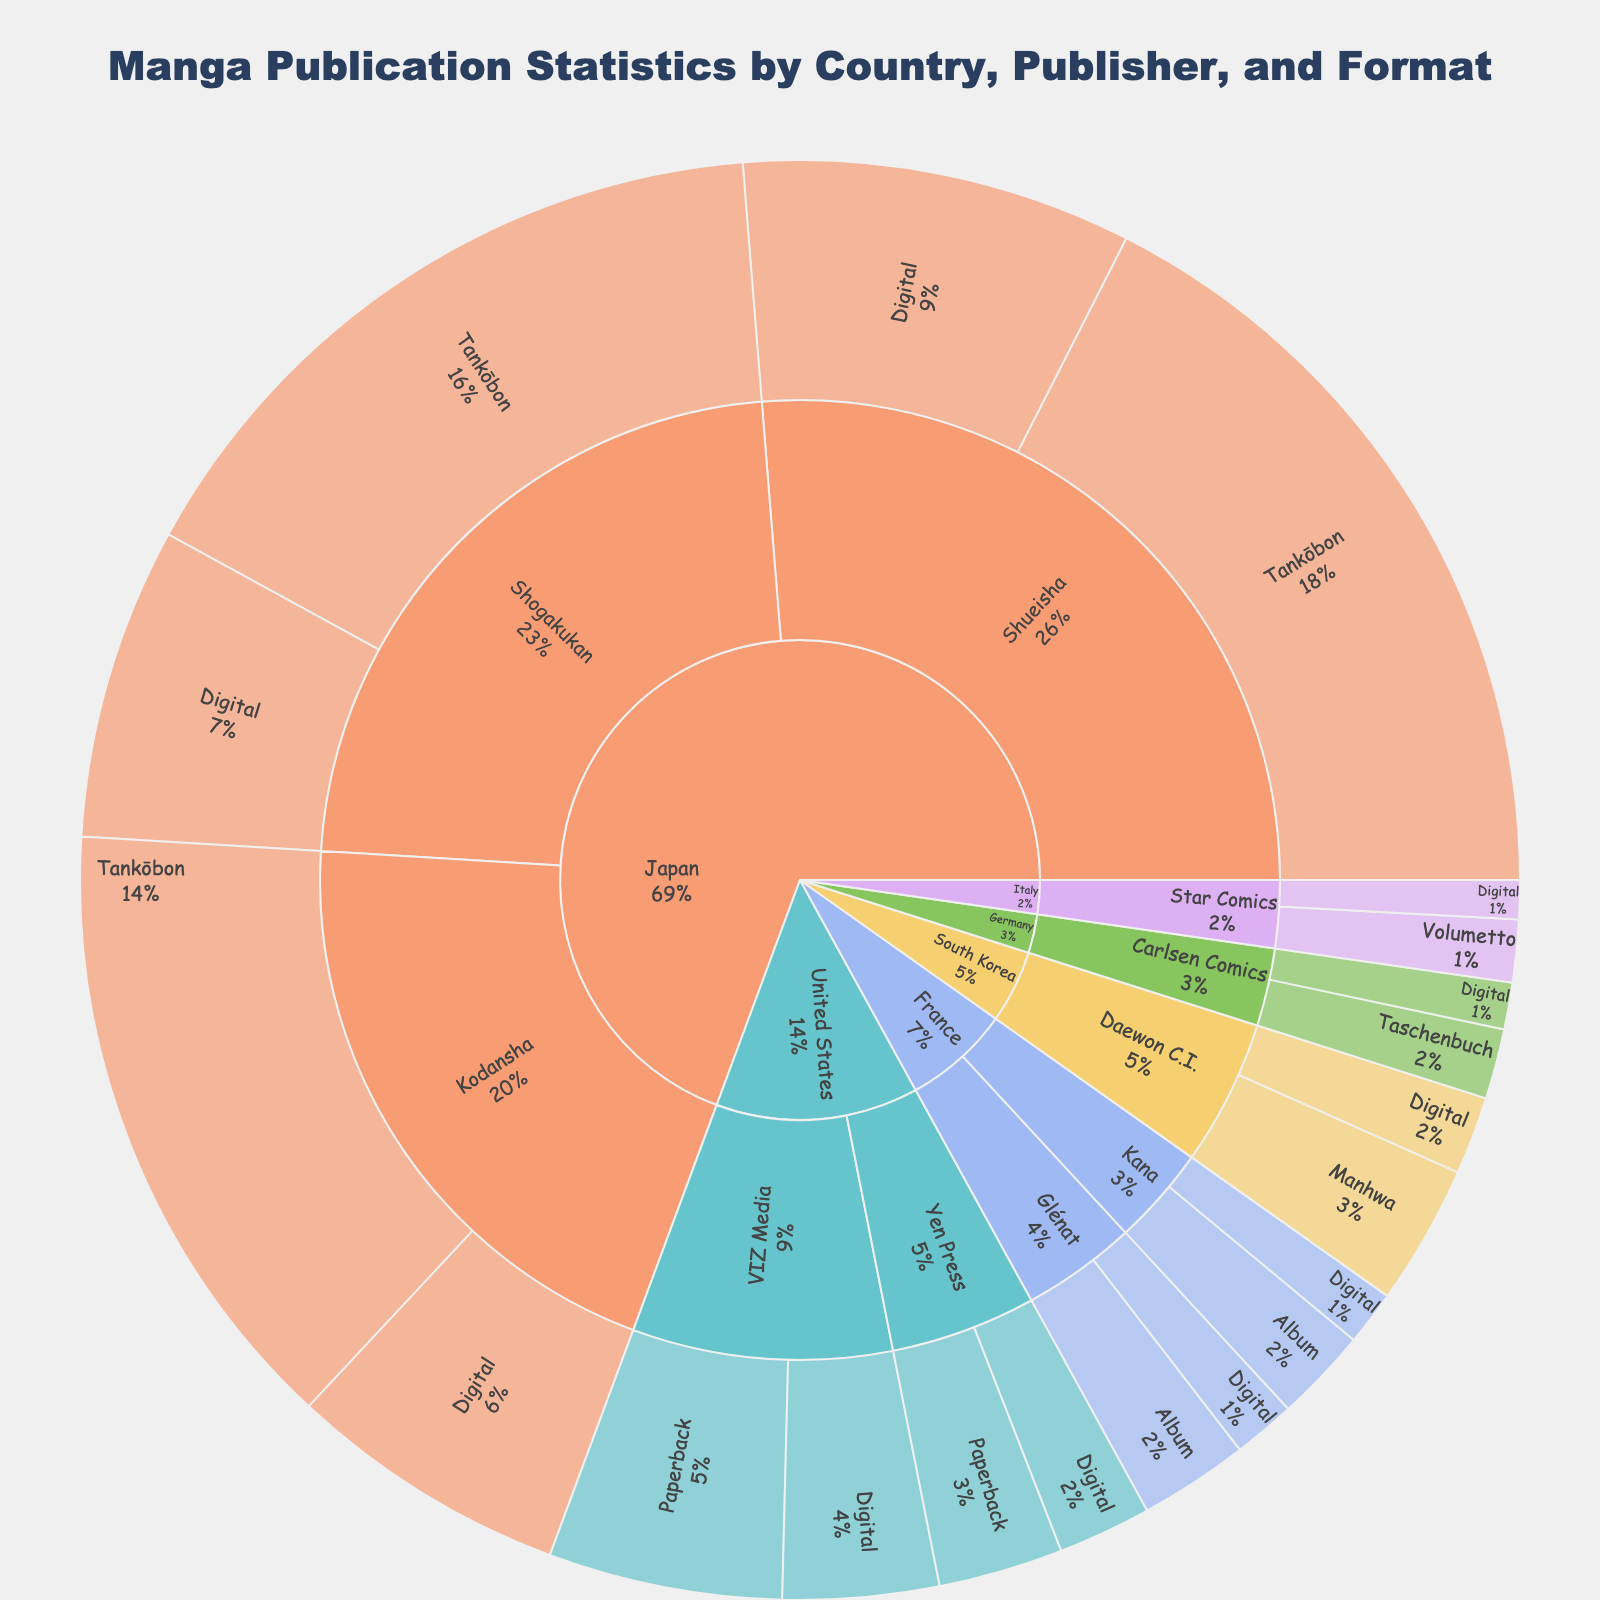What is the title of the plot? The title of the plot is displayed at the top center. It provides a summary of what the visualization represents.
Answer: Manga Publication Statistics by Country, Publisher, and Format Which country has the highest total value of manga publications? By looking at the largest overall segment in the sunburst plot, it is evident which country contributes the most.
Answer: Japan How many different publication formats are used in Japan? By observing the divisions within the Japan segment of the sunburst plot, the number of different formats can be counted.
Answer: 4 What is the combined value for all publications under Shueisha? Summing up the values for both Tankōbon and Digital formats under Shueisha in the Japan segment.
Answer: 750 Which publisher in France has the higher total value of manga publications? By comparing the total value segments under Glénat and Kana in the France section of the sunburst plot.
Answer: Glénat What's the difference in total publication values between VIZ Media and Yen Press in the United States? Subtract the combined value of Yen Press's formats from VIZ Media's formats. VIZ Media: 150 + 100 = 250, Yen Press: 80 + 60 = 140, Difference: 250 - 140
Answer: 110 What's the percentage contribution of Digital publications in Japan under Kodansha? Dividing the Digital value by the total value of Kodansha publications and converting to a percentage.
Answer: (180 / (400 + 180)) * 100 = 31% Which country has the lowest total value of manga publications? By finding the smallest overall segment in the outer ring of the sunburst plot, the country with the lowest total can be identified.
Answer: Italy How does the publication value of Paperback formats in the United States compare to Digital formats in the same country? By comparing the values of Paperback and Digital formats for both VIZ Media and Yen Press in the US segment. Total Paperback: 230 (150+80), Total Digital: 160 (100+60)
Answer: Paperback is higher What is the combined total value for all Digital publications across all countries? Summing up the values from the Digital segments for each publisher and country shown in the sunburst plot: Japan (200 + 180 + 250) + USA (100 + 60) + France (40 + 35) + S. Korea (50) + Germany (30) + Italy (25).
Answer: 970 